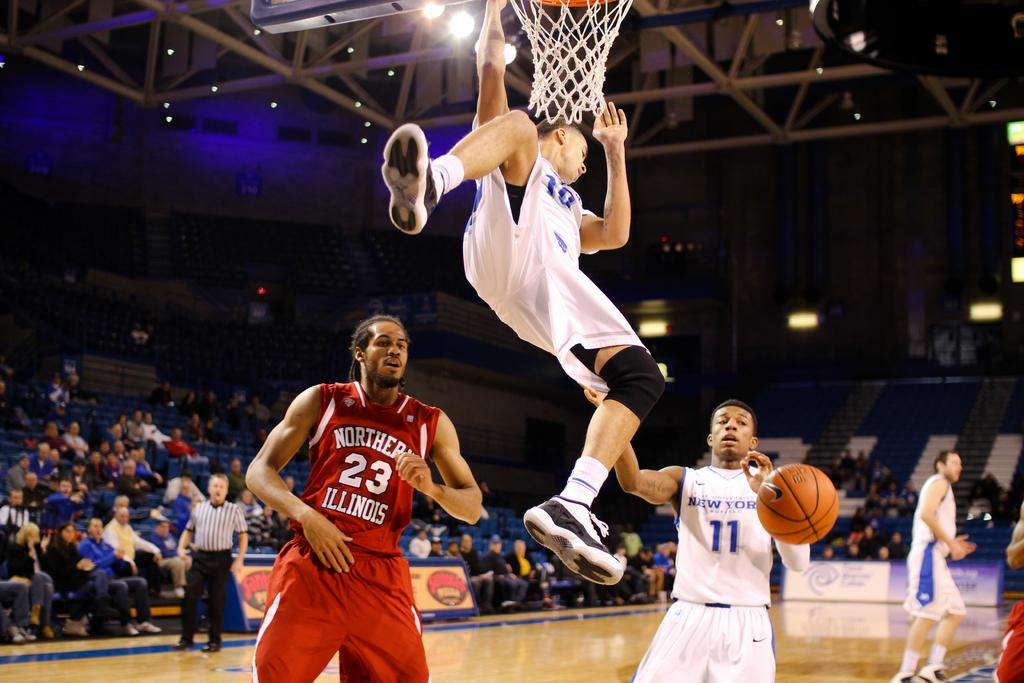Provide a one-sentence caption for the provided image. A basketball player wearing a white uniform soars over number 23 from the red team. 